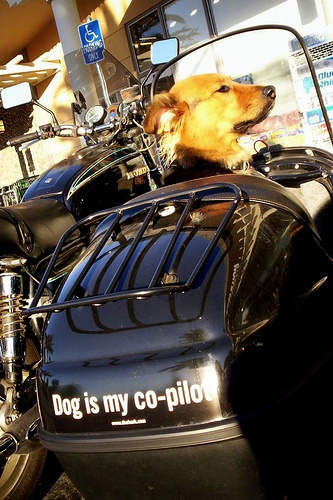Describe the objects in this image and their specific colors. I can see motorcycle in maroon, black, ivory, and gray tones, motorcycle in maroon, black, and ivory tones, and dog in maroon, gold, orange, black, and khaki tones in this image. 